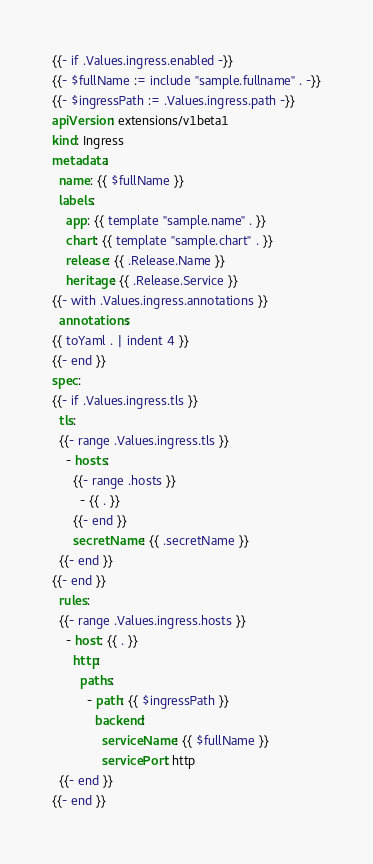<code> <loc_0><loc_0><loc_500><loc_500><_YAML_>{{- if .Values.ingress.enabled -}}
{{- $fullName := include "sample.fullname" . -}}
{{- $ingressPath := .Values.ingress.path -}}
apiVersion: extensions/v1beta1
kind: Ingress
metadata:
  name: {{ $fullName }}
  labels:
    app: {{ template "sample.name" . }}
    chart: {{ template "sample.chart" . }}
    release: {{ .Release.Name }}
    heritage: {{ .Release.Service }}
{{- with .Values.ingress.annotations }}
  annotations:
{{ toYaml . | indent 4 }}
{{- end }}
spec:
{{- if .Values.ingress.tls }}
  tls:
  {{- range .Values.ingress.tls }}
    - hosts:
      {{- range .hosts }}
        - {{ . }}
      {{- end }}
      secretName: {{ .secretName }}
  {{- end }}
{{- end }}
  rules:
  {{- range .Values.ingress.hosts }}
    - host: {{ . }}
      http:
        paths:
          - path: {{ $ingressPath }}
            backend:
              serviceName: {{ $fullName }}
              servicePort: http
  {{- end }}
{{- end }}
</code> 